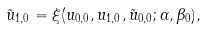<formula> <loc_0><loc_0><loc_500><loc_500>\tilde { u } _ { 1 , 0 } = \xi ( u _ { 0 , 0 } , u _ { 1 , 0 } , \tilde { u } _ { 0 , 0 } ; \alpha , \beta _ { 0 } ) ,</formula> 